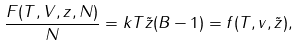<formula> <loc_0><loc_0><loc_500><loc_500>\frac { F ( T , V , z , N ) } { N } = k T \tilde { z } ( B - 1 ) = f ( T , v , \tilde { z } ) ,</formula> 